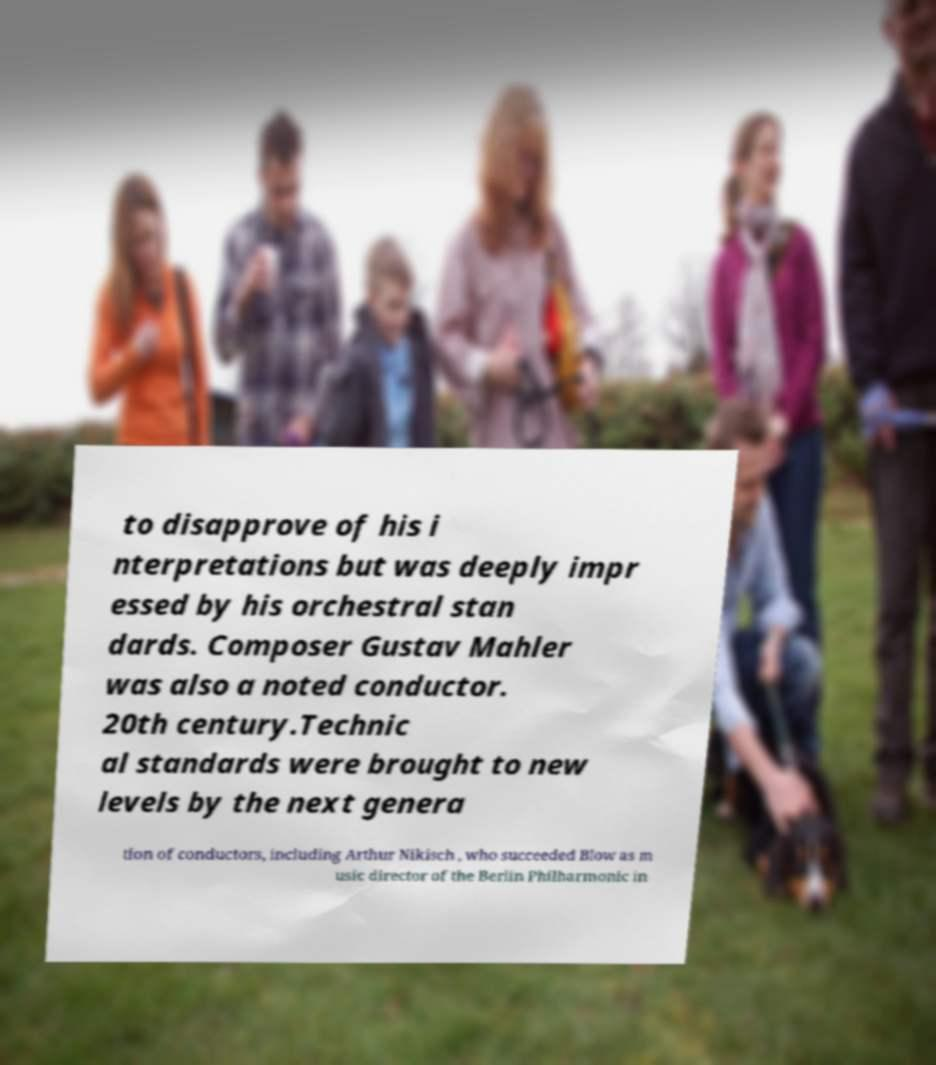I need the written content from this picture converted into text. Can you do that? to disapprove of his i nterpretations but was deeply impr essed by his orchestral stan dards. Composer Gustav Mahler was also a noted conductor. 20th century.Technic al standards were brought to new levels by the next genera tion of conductors, including Arthur Nikisch , who succeeded Blow as m usic director of the Berlin Philharmonic in 